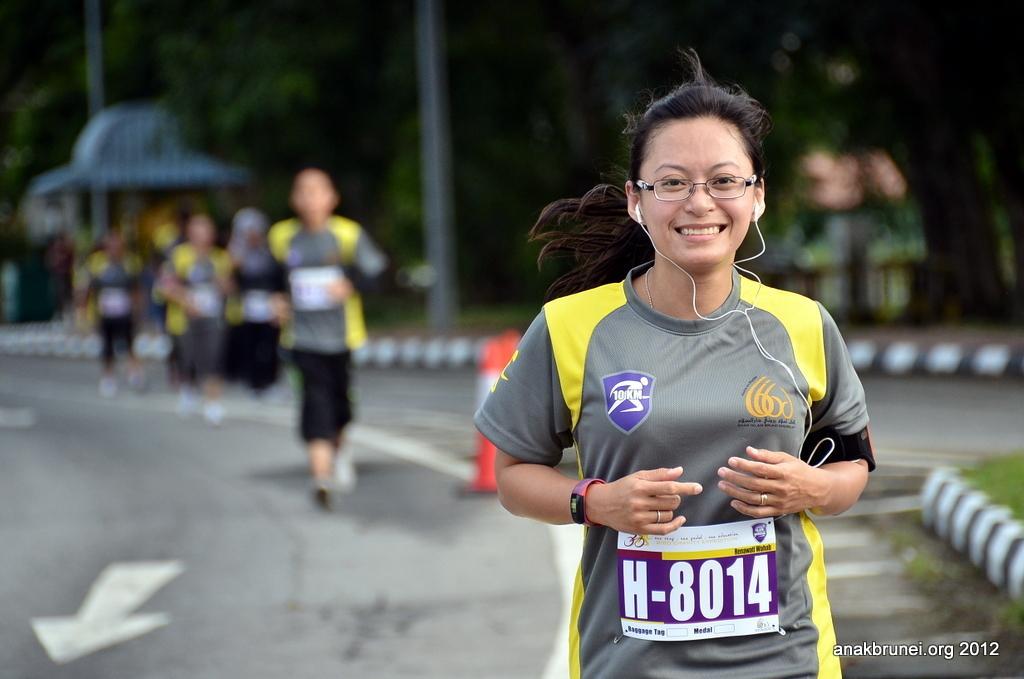Can you describe this image briefly? In this image we can see one woman with spectacles wearing earphones, some people running on the road, some safety poles on the road, one shed, one green object on the ground looks like a dustbin, two poles, some trees, some grass on the ground and the background is blurred. 